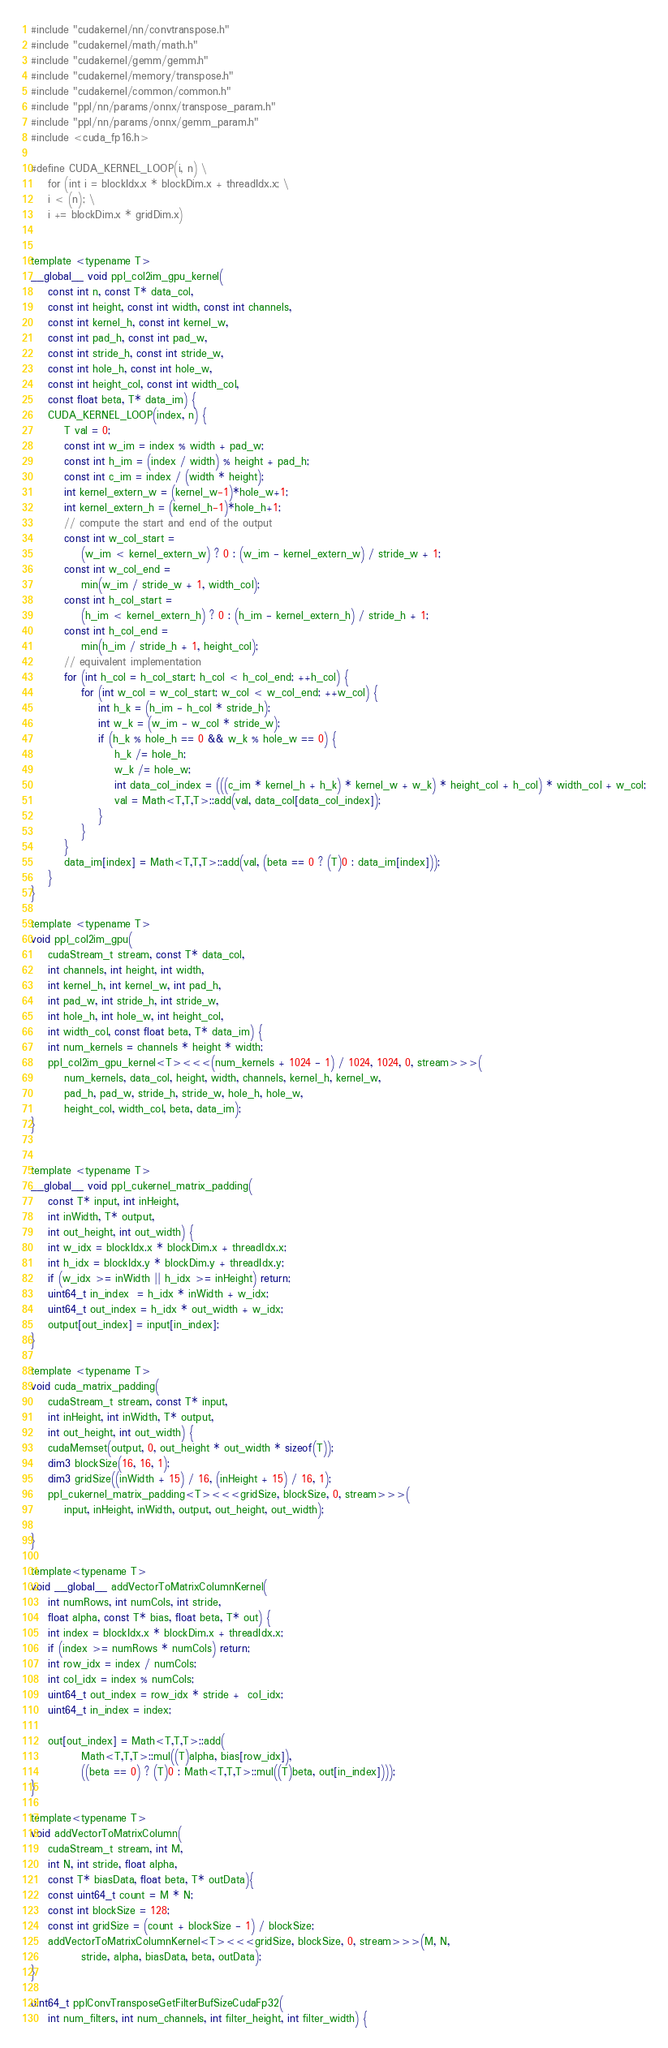Convert code to text. <code><loc_0><loc_0><loc_500><loc_500><_Cuda_>#include "cudakernel/nn/convtranspose.h"
#include "cudakernel/math/math.h"
#include "cudakernel/gemm/gemm.h"
#include "cudakernel/memory/transpose.h"
#include "cudakernel/common/common.h"
#include "ppl/nn/params/onnx/transpose_param.h"
#include "ppl/nn/params/onnx/gemm_param.h"
#include <cuda_fp16.h>

#define CUDA_KERNEL_LOOP(i, n) \
	for (int i = blockIdx.x * blockDim.x + threadIdx.x; \
	i < (n); \
	i += blockDim.x * gridDim.x)


template <typename T>
__global__ void ppl_col2im_gpu_kernel(
    const int n, const T* data_col,
    const int height, const int width, const int channels,
    const int kernel_h, const int kernel_w,
    const int pad_h, const int pad_w,
    const int stride_h, const int stride_w,
    const int hole_h, const int hole_w,
    const int height_col, const int width_col,
    const float beta, T* data_im) {
    CUDA_KERNEL_LOOP(index, n) {
        T val = 0;
        const int w_im = index % width + pad_w;
        const int h_im = (index / width) % height + pad_h;
        const int c_im = index / (width * height);
        int kernel_extern_w = (kernel_w-1)*hole_w+1;
        int kernel_extern_h = (kernel_h-1)*hole_h+1;
        // compute the start and end of the output
        const int w_col_start =
            (w_im < kernel_extern_w) ? 0 : (w_im - kernel_extern_w) / stride_w + 1;
        const int w_col_end =
            min(w_im / stride_w + 1, width_col);
        const int h_col_start =
            (h_im < kernel_extern_h) ? 0 : (h_im - kernel_extern_h) / stride_h + 1;
        const int h_col_end =
            min(h_im / stride_h + 1, height_col);
        // equivalent implementation
        for (int h_col = h_col_start; h_col < h_col_end; ++h_col) {
            for (int w_col = w_col_start; w_col < w_col_end; ++w_col) {
                int h_k = (h_im - h_col * stride_h);
                int w_k = (w_im - w_col * stride_w);
                if (h_k % hole_h == 0 && w_k % hole_w == 0) {
                    h_k /= hole_h;
                    w_k /= hole_w;
                    int data_col_index = (((c_im * kernel_h + h_k) * kernel_w + w_k) * height_col + h_col) * width_col + w_col;
	                val = Math<T,T,T>::add(val, data_col[data_col_index]);
                }
            }
        }
        data_im[index] = Math<T,T,T>::add(val, (beta == 0 ? (T)0 : data_im[index]));
    }
}

template <typename T>
void ppl_col2im_gpu(
    cudaStream_t stream, const T* data_col,
    int channels, int height, int width,
    int kernel_h, int kernel_w, int pad_h,
    int pad_w, int stride_h, int stride_w,
    int hole_h, int hole_w, int height_col,
    int width_col, const float beta, T* data_im) {
    int num_kernels = channels * height * width;
    ppl_col2im_gpu_kernel<T><<<(num_kernels + 1024 - 1) / 1024, 1024, 0, stream>>>(
        num_kernels, data_col, height, width, channels, kernel_h, kernel_w,
        pad_h, pad_w, stride_h, stride_w, hole_h, hole_w,
        height_col, width_col, beta, data_im);
}


template <typename T>
__global__ void ppl_cukernel_matrix_padding(
    const T* input, int inHeight,
    int inWidth, T* output,
    int out_height, int out_width) {
    int w_idx = blockIdx.x * blockDim.x + threadIdx.x;
    int h_idx = blockIdx.y * blockDim.y + threadIdx.y;
    if (w_idx >= inWidth || h_idx >= inHeight) return;
    uint64_t in_index  = h_idx * inWidth + w_idx;
    uint64_t out_index = h_idx * out_width + w_idx;
    output[out_index] = input[in_index];
}

template <typename T>
void cuda_matrix_padding(
    cudaStream_t stream, const T* input,
    int inHeight, int inWidth, T* output,
    int out_height, int out_width) {
    cudaMemset(output, 0, out_height * out_width * sizeof(T));
    dim3 blockSize(16, 16, 1);
    dim3 gridSize((inWidth + 15) / 16, (inHeight + 15) / 16, 1);
    ppl_cukernel_matrix_padding<T><<<gridSize, blockSize, 0, stream>>>(
        input, inHeight, inWidth, output, out_height, out_width);

}

template<typename T>
void __global__ addVectorToMatrixColumnKernel(
    int numRows, int numCols, int stride,
    float alpha, const T* bias, float beta, T* out) {
    int index = blockIdx.x * blockDim.x + threadIdx.x;
    if (index >= numRows * numCols) return;
    int row_idx = index / numCols;
    int col_idx = index % numCols;
    uint64_t out_index = row_idx * stride +  col_idx;
    uint64_t in_index = index;

    out[out_index] = Math<T,T,T>::add(
		    Math<T,T,T>::mul((T)alpha, bias[row_idx]),
			((beta == 0) ? (T)0 : Math<T,T,T>::mul((T)beta, out[in_index])));
}

template<typename T>
void addVectorToMatrixColumn(
    cudaStream_t stream, int M,
    int N, int stride, float alpha,
    const T* biasData, float beta, T* outData){
    const uint64_t count = M * N;
    const int blockSize = 128;
    const int gridSize = (count + blockSize - 1) / blockSize;
    addVectorToMatrixColumnKernel<T><<<gridSize, blockSize, 0, stream>>>(M, N,
            stride, alpha, biasData, beta, outData);
}

uint64_t pplConvTransposeGetFilterBufSizeCudaFp32(
    int num_filters, int num_channels, int filter_height, int filter_width) {</code> 